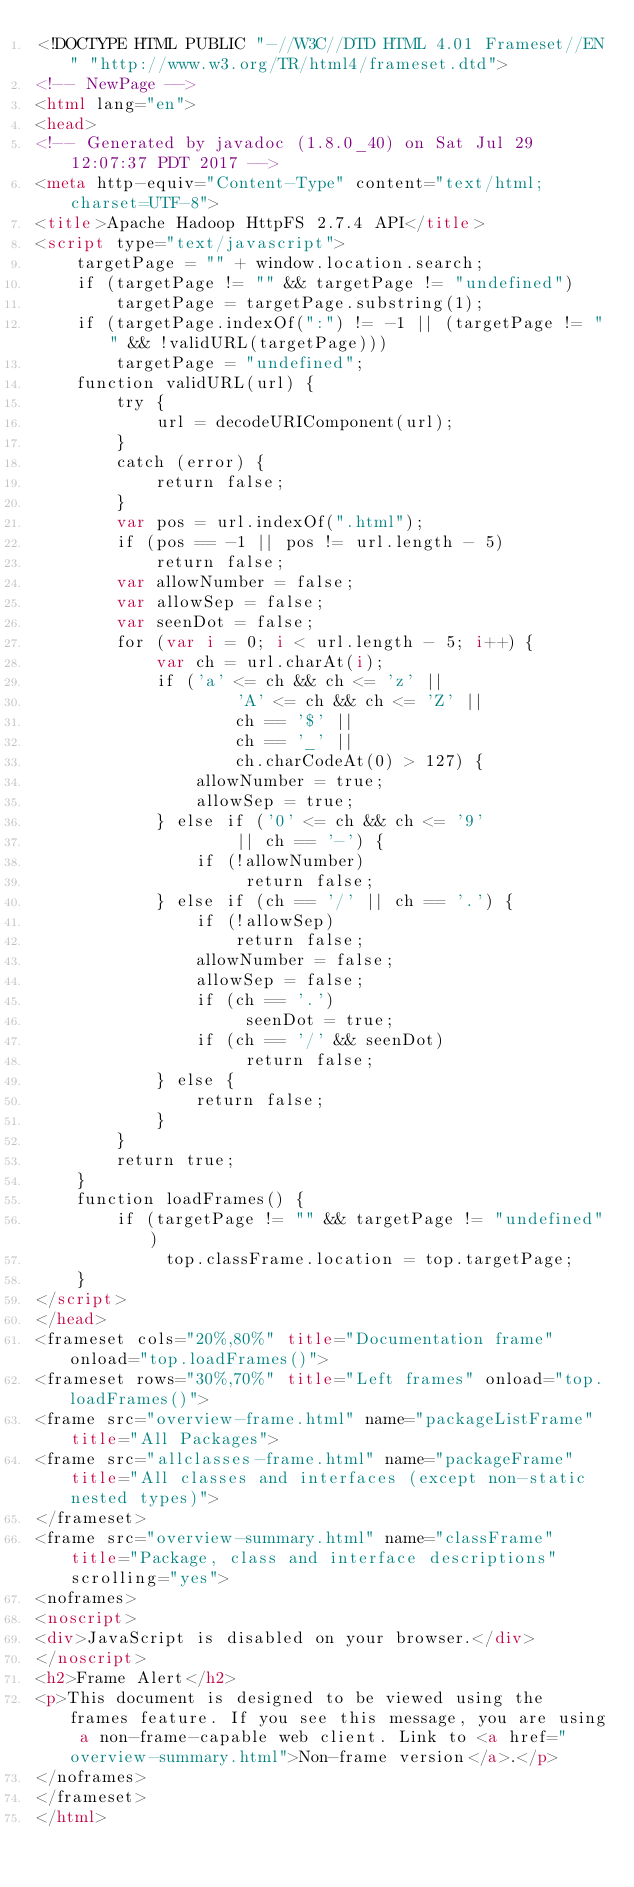<code> <loc_0><loc_0><loc_500><loc_500><_HTML_><!DOCTYPE HTML PUBLIC "-//W3C//DTD HTML 4.01 Frameset//EN" "http://www.w3.org/TR/html4/frameset.dtd">
<!-- NewPage -->
<html lang="en">
<head>
<!-- Generated by javadoc (1.8.0_40) on Sat Jul 29 12:07:37 PDT 2017 -->
<meta http-equiv="Content-Type" content="text/html; charset=UTF-8">
<title>Apache Hadoop HttpFS 2.7.4 API</title>
<script type="text/javascript">
    targetPage = "" + window.location.search;
    if (targetPage != "" && targetPage != "undefined")
        targetPage = targetPage.substring(1);
    if (targetPage.indexOf(":") != -1 || (targetPage != "" && !validURL(targetPage)))
        targetPage = "undefined";
    function validURL(url) {
        try {
            url = decodeURIComponent(url);
        }
        catch (error) {
            return false;
        }
        var pos = url.indexOf(".html");
        if (pos == -1 || pos != url.length - 5)
            return false;
        var allowNumber = false;
        var allowSep = false;
        var seenDot = false;
        for (var i = 0; i < url.length - 5; i++) {
            var ch = url.charAt(i);
            if ('a' <= ch && ch <= 'z' ||
                    'A' <= ch && ch <= 'Z' ||
                    ch == '$' ||
                    ch == '_' ||
                    ch.charCodeAt(0) > 127) {
                allowNumber = true;
                allowSep = true;
            } else if ('0' <= ch && ch <= '9'
                    || ch == '-') {
                if (!allowNumber)
                     return false;
            } else if (ch == '/' || ch == '.') {
                if (!allowSep)
                    return false;
                allowNumber = false;
                allowSep = false;
                if (ch == '.')
                     seenDot = true;
                if (ch == '/' && seenDot)
                     return false;
            } else {
                return false;
            }
        }
        return true;
    }
    function loadFrames() {
        if (targetPage != "" && targetPage != "undefined")
             top.classFrame.location = top.targetPage;
    }
</script>
</head>
<frameset cols="20%,80%" title="Documentation frame" onload="top.loadFrames()">
<frameset rows="30%,70%" title="Left frames" onload="top.loadFrames()">
<frame src="overview-frame.html" name="packageListFrame" title="All Packages">
<frame src="allclasses-frame.html" name="packageFrame" title="All classes and interfaces (except non-static nested types)">
</frameset>
<frame src="overview-summary.html" name="classFrame" title="Package, class and interface descriptions" scrolling="yes">
<noframes>
<noscript>
<div>JavaScript is disabled on your browser.</div>
</noscript>
<h2>Frame Alert</h2>
<p>This document is designed to be viewed using the frames feature. If you see this message, you are using a non-frame-capable web client. Link to <a href="overview-summary.html">Non-frame version</a>.</p>
</noframes>
</frameset>
</html>
</code> 